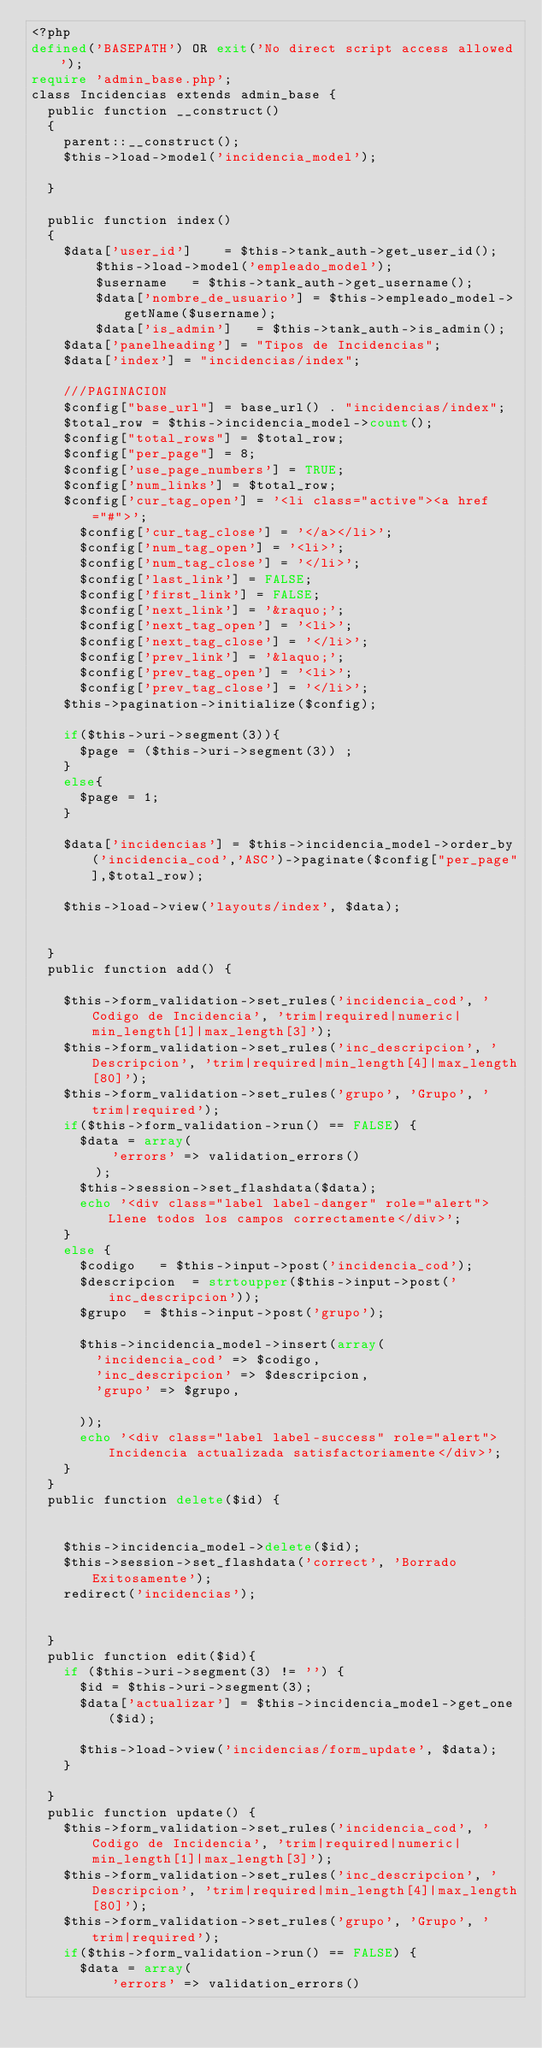<code> <loc_0><loc_0><loc_500><loc_500><_PHP_><?php
defined('BASEPATH') OR exit('No direct script access allowed');
require 'admin_base.php';
class Incidencias extends admin_base {
	public function __construct()
	{
		parent::__construct();
		$this->load->model('incidencia_model');
		
	}

	public function index()
	{
		$data['user_id']    = $this->tank_auth->get_user_id();
        $this->load->model('empleado_model');
        $username   = $this->tank_auth->get_username();
        $data['nombre_de_usuario'] = $this->empleado_model->getName($username);
        $data['is_admin']   = $this->tank_auth->is_admin();
		$data['panelheading'] = "Tipos de Incidencias";
		$data['index'] = "incidencias/index";
		
		///PAGINACION
		$config["base_url"] = base_url() . "incidencias/index";
		$total_row = $this->incidencia_model->count();
		$config["total_rows"] = $total_row;
		$config["per_page"] = 8;
		$config['use_page_numbers'] = TRUE;
		$config['num_links'] = $total_row;
		$config['cur_tag_open'] = '<li class="active"><a href="#">';
	    $config['cur_tag_close'] = '</a></li>';
	    $config['num_tag_open'] = '<li>';
	    $config['num_tag_close'] = '</li>';
	    $config['last_link'] = FALSE;
	    $config['first_link'] = FALSE;
	    $config['next_link'] = '&raquo;';
	    $config['next_tag_open'] = '<li>';
	    $config['next_tag_close'] = '</li>';
	    $config['prev_link'] = '&laquo;';
	    $config['prev_tag_open'] = '<li>';
	    $config['prev_tag_close'] = '</li>';
		$this->pagination->initialize($config); 
		  
		if($this->uri->segment(3)){
			$page = ($this->uri->segment(3)) ;
		}
		else{
			$page = 1;
		}

		$data['incidencias'] = $this->incidencia_model->order_by('incidencia_cod','ASC')->paginate($config["per_page"],$total_row);

		$this->load->view('layouts/index', $data);

		
	}
	public function add() {
		
		$this->form_validation->set_rules('incidencia_cod', 'Codigo de Incidencia', 'trim|required|numeric|min_length[1]|max_length[3]');
		$this->form_validation->set_rules('inc_descripcion', 'Descripcion', 'trim|required|min_length[4]|max_length[80]');
		$this->form_validation->set_rules('grupo', 'Grupo', 'trim|required');
		if($this->form_validation->run() == FALSE) {
			$data = array(
					'errors' => validation_errors()
				);
			$this->session->set_flashdata($data);
			echo '<div class="label label-danger" role="alert">Llene todos los campos correctamente</div>';
		}
		else {
			$codigo 	= $this->input->post('incidencia_cod');
			$descripcion 	= strtoupper($this->input->post('inc_descripcion'));
			$grupo 	= $this->input->post('grupo');

			$this->incidencia_model->insert(array(
				'incidencia_cod' => $codigo,
				'inc_descripcion' => $descripcion,
				'grupo' => $grupo,
			
			));
			echo '<div class="label label-success" role="alert">Incidencia actualizada satisfactoriamente</div>';
		}
	}
	public function delete($id) {

		
		$this->incidencia_model->delete($id);
		$this->session->set_flashdata('correct', 'Borrado Exitosamente');
		redirect('incidencias');
		
	
	}
	public function edit($id){
		if ($this->uri->segment(3) != '') {
			$id = $this->uri->segment(3);
			$data['actualizar'] = $this->incidencia_model->get_one($id);
						
			$this->load->view('incidencias/form_update', $data);	
		}
		
	}
	public function update() {
		$this->form_validation->set_rules('incidencia_cod', 'Codigo de Incidencia', 'trim|required|numeric|min_length[1]|max_length[3]');
		$this->form_validation->set_rules('inc_descripcion', 'Descripcion', 'trim|required|min_length[4]|max_length[80]');
		$this->form_validation->set_rules('grupo', 'Grupo', 'trim|required');
		if($this->form_validation->run() == FALSE) {
			$data = array(
					'errors' => validation_errors()</code> 